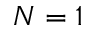Convert formula to latex. <formula><loc_0><loc_0><loc_500><loc_500>N = 1</formula> 